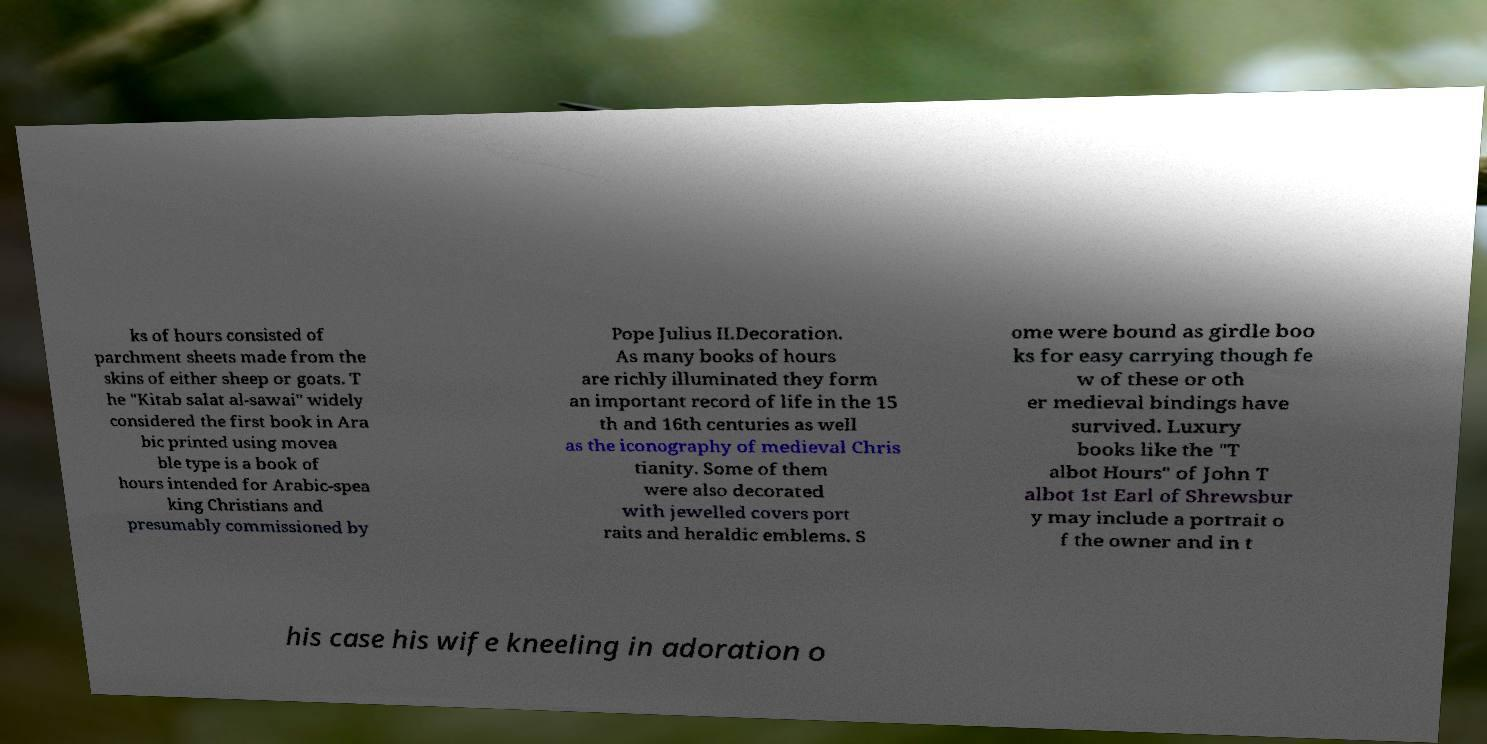Can you accurately transcribe the text from the provided image for me? ks of hours consisted of parchment sheets made from the skins of either sheep or goats. T he "Kitab salat al-sawai" widely considered the first book in Ara bic printed using movea ble type is a book of hours intended for Arabic-spea king Christians and presumably commissioned by Pope Julius II.Decoration. As many books of hours are richly illuminated they form an important record of life in the 15 th and 16th centuries as well as the iconography of medieval Chris tianity. Some of them were also decorated with jewelled covers port raits and heraldic emblems. S ome were bound as girdle boo ks for easy carrying though fe w of these or oth er medieval bindings have survived. Luxury books like the "T albot Hours" of John T albot 1st Earl of Shrewsbur y may include a portrait o f the owner and in t his case his wife kneeling in adoration o 